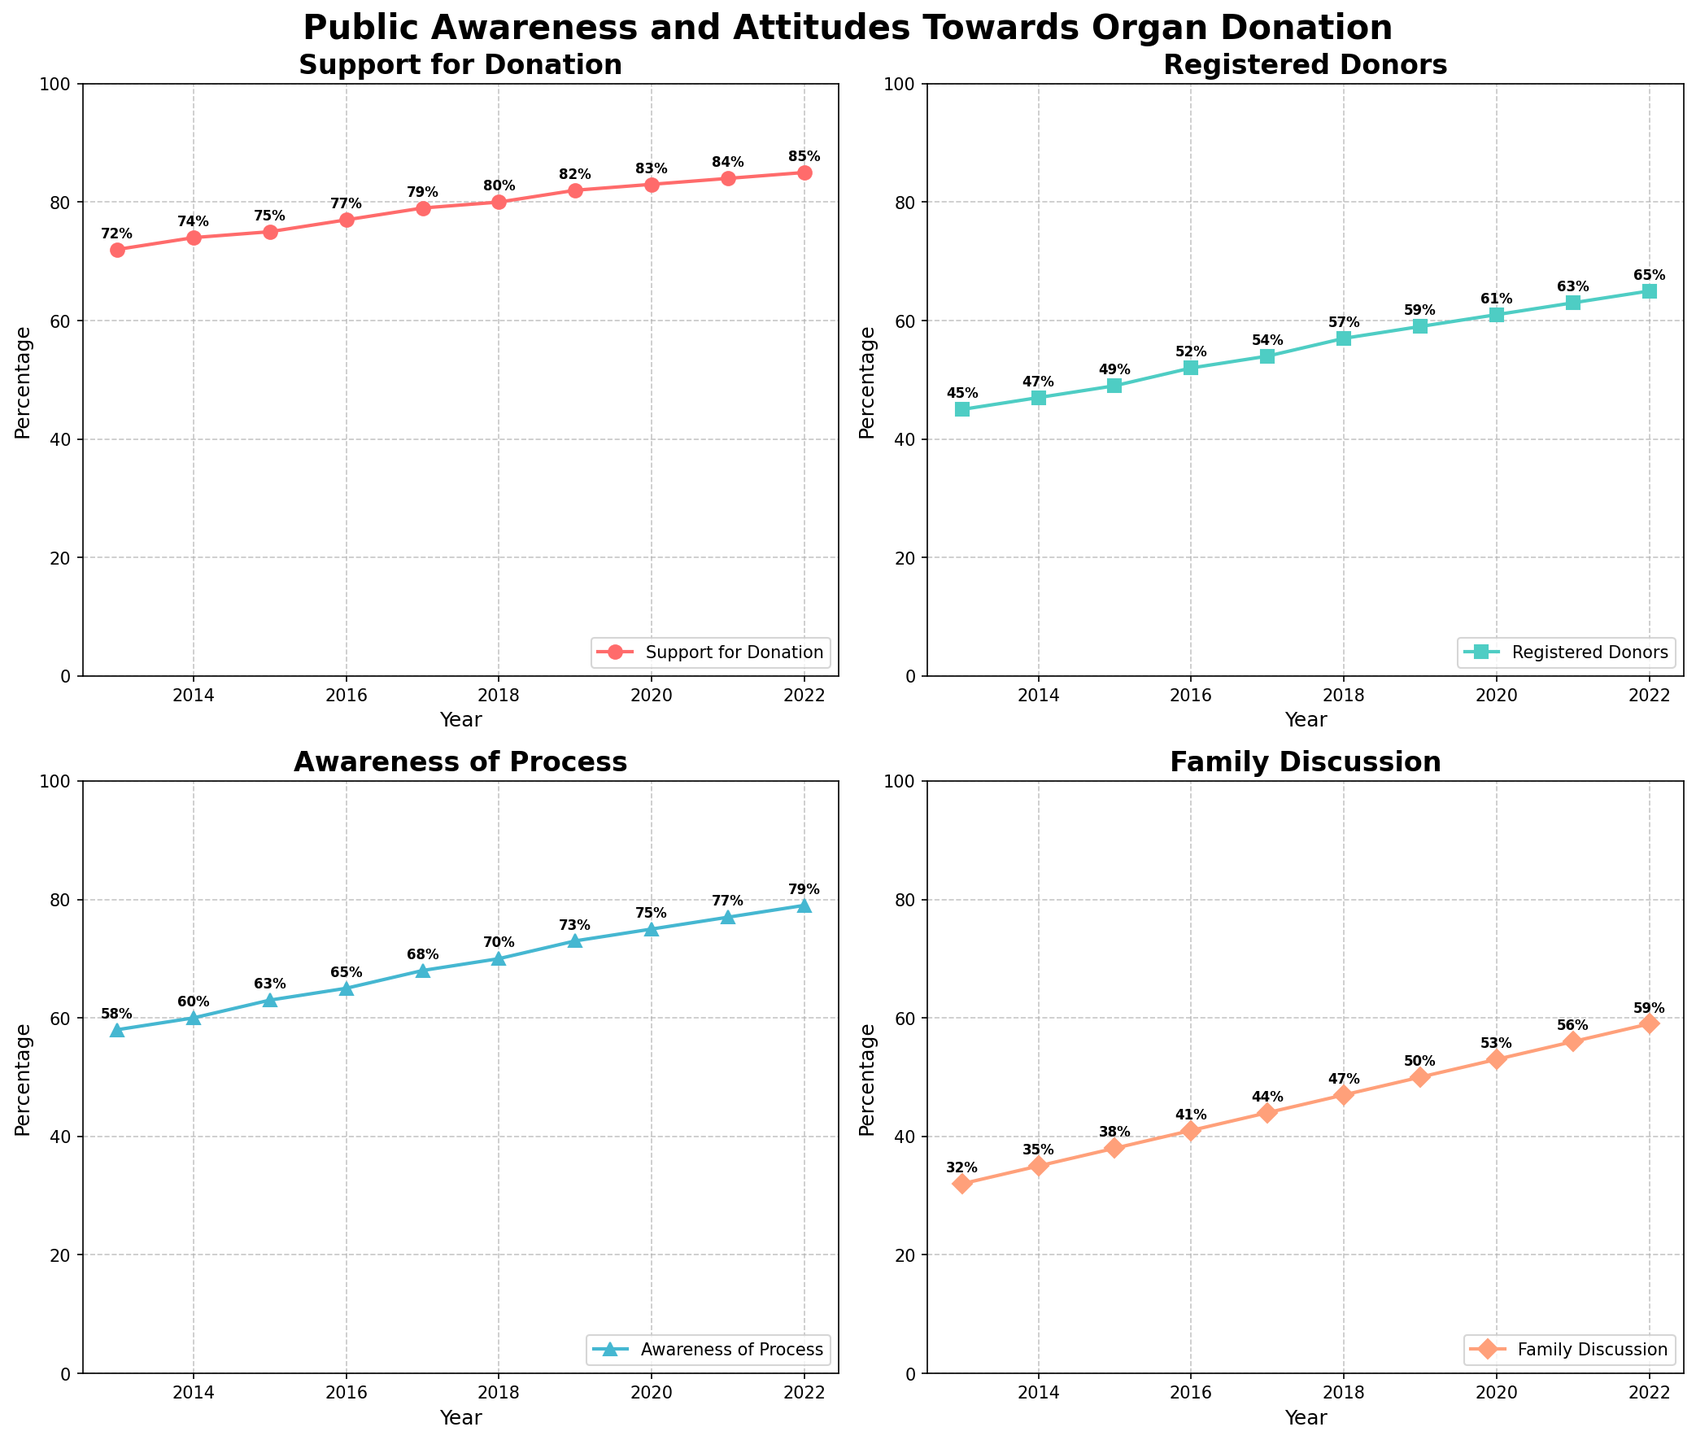Which year saw the highest percentage of registered donors? The subplot for Registered Donors shows a line rising from 2013 to 2022. The highest point on this line occurs in 2022.
Answer: 2022 What is the difference in family discussion about organ donation between 2013 and 2022? The subplot for Family Discussion shows the value for 2013 at 32% and for 2022 at 59%. The difference is 59% - 32% = 27%.
Answer: 27% Which metric had the highest percentage increase from 2013 to 2022? By examining the starting and ending points for each subplot: Support_for_Donation increases from 72% to 85%, Registered_Donors from 45% to 65%, Awareness_of_Process from 58% to 79%, and Family_Discussion from 32% to 59%. The highest difference is in Awareness_of_Process with an increase of 21%.
Answer: Awareness_of_Process How many years did it take for the percentage of support for organ donation to reach 80%? The subplot for Support for Donation reaches 80% in 2018. Since it starts in 2013, this takes 2018 - 2013 = 5 years.
Answer: 5 years In which year did the family discussion rate surpass 50%? In the subplot for Family Discussion, the line passes the 50% mark in 2019.
Answer: 2019 By how much did the awareness of the organ donation process increase between 2014 and 2016? The subplot for Awareness of Process shows the value in 2014 as 60% and in 2016 as 65%. The difference is 65% - 60% = 5%.
Answer: 5% Compare the trend of Trust in System to that of Registered Donors; what do you observe about their growth patterns? Both subplots indicate an upward trend. Trust in System grows steadily from 68% in 2013 to 81% in 2022, while Registered Donors grow from 45% to 65% over the same period. Both grow, but Trust in System has a higher starting and ending percentage.
Answer: Both increase, but Trust in System grows from a higher base What is the average percentage of support for organ donation over the decade shown? The percentages from 2013 to 2022 are 72, 74, 75, 77, 79, 80, 82, 83, 84, and 85. Adding these gives 791. The average is 791 / 10 = 79.1%.
Answer: 79.1% Which year did the awareness of the organ donation process and trust in the system both surpass 75%? In the subplots, Awareness of Process and Trust in System both surpass 75% in 2020.
Answer: 2020 